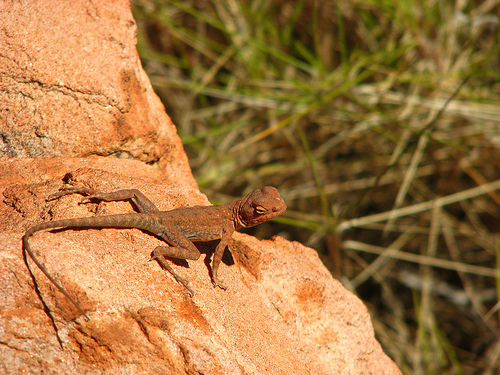<image>
Is the lizard in the rock? No. The lizard is not contained within the rock. These objects have a different spatial relationship. 